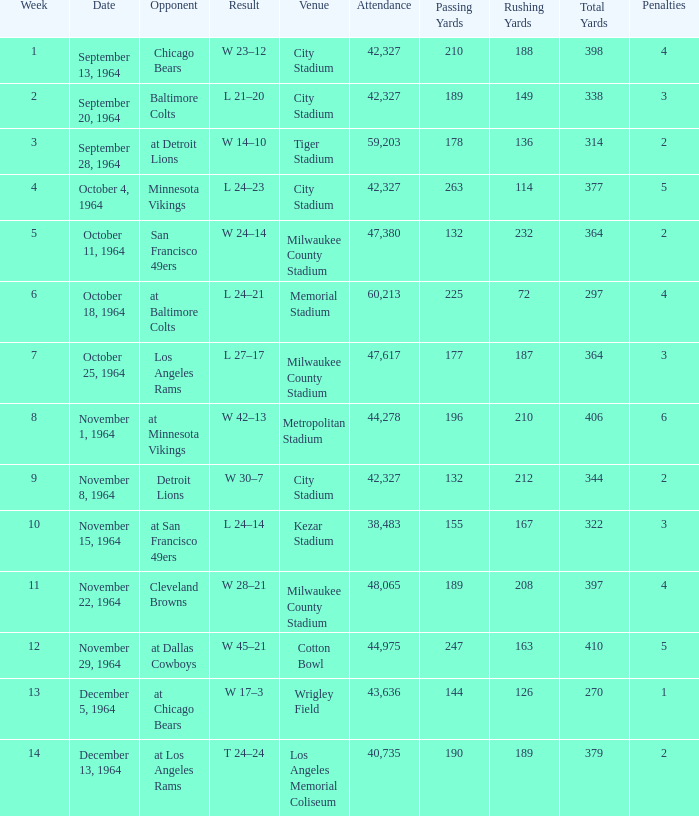What is the typical number of attendees for a game in week 4? 42327.0. 